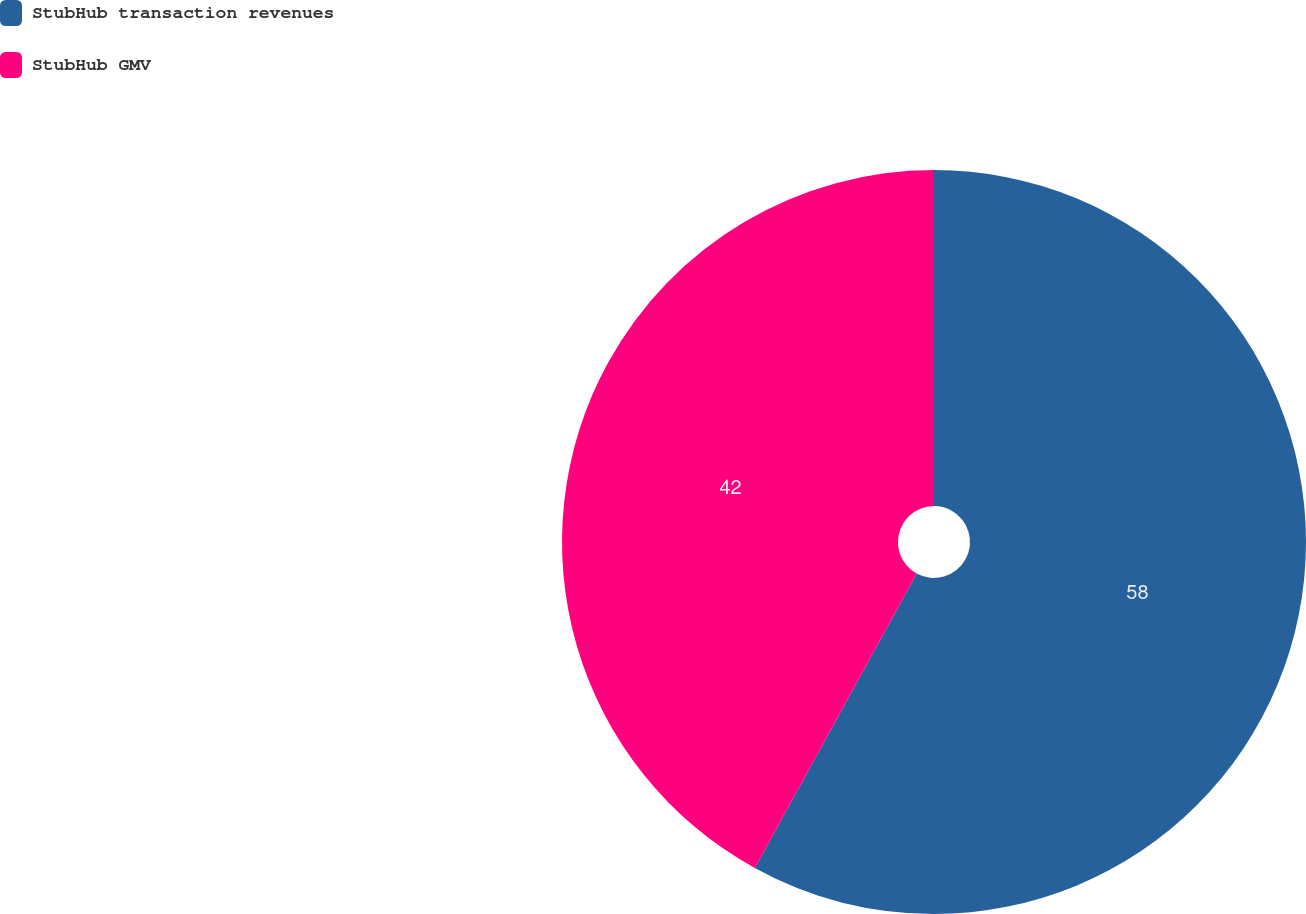Convert chart to OTSL. <chart><loc_0><loc_0><loc_500><loc_500><pie_chart><fcel>StubHub transaction revenues<fcel>StubHub GMV<nl><fcel>58.0%<fcel>42.0%<nl></chart> 